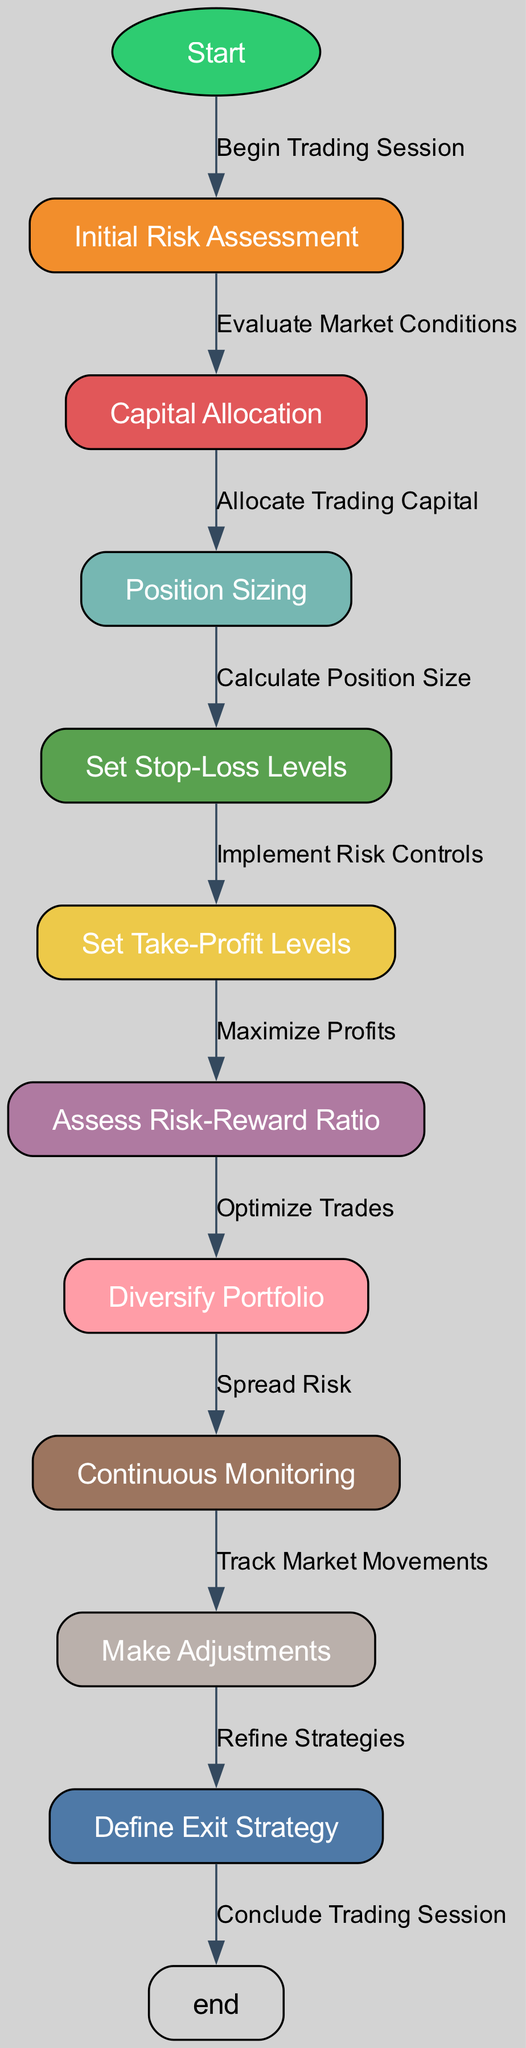What is the starting point of the flowchart? The flowchart begins at the "Start" node. This node is labeled as "Start" and is the initial point where the trading session begins.
Answer: Start How many nodes are there in total? Counting the listed nodes in the provided data, there are a total of 11 nodes including the start and end nodes.
Answer: 11 What node follows "Set Stop-Loss Levels"? According to the flow of the diagram, the node that follows "Set Stop-Loss Levels" is "Set Take-Profit Levels." This indicates the sequential decisions in risk management strategies.
Answer: Set Take-Profit Levels What is the purpose of the "Assess Risk-Reward Ratio" node? The "Assess Risk-Reward Ratio" node is about evaluating the potential reward versus the risk involved in the trades, which is crucial for making informed trading decisions.
Answer: Assess Risk-Reward Ratio Which node is immediately before "Define Exit Strategy"? The node immediately before "Define Exit Strategy" is "Make Adjustments." This shows that adjustments to strategies must be made before defining how to exit the trades.
Answer: Make Adjustments What is the last step in this flowchart? The last step in the flowchart is "Conclude Trading Session." This indicates that after completing all previous steps, the trading session reaches its end.
Answer: Conclude Trading Session Which node represents the process of spreading the risk? The node labeled "Diversify Portfolio" represents the process of spreading the risk by investing in different assets or trades to minimize potential losses.
Answer: Diversify Portfolio What does the arrow from "Initial Risk Assessment" lead to? The arrow from "Initial Risk Assessment" leads to "Capital Allocation," indicating that after assessing the risks, the next step is to allocate the necessary capital for trading.
Answer: Capital Allocation What is emphasized by the node "Continuous Monitoring"? "Continuous Monitoring" emphasizes the importance of tracking market movements consistently throughout the trading process to adjust strategies as necessary.
Answer: Continuous Monitoring 